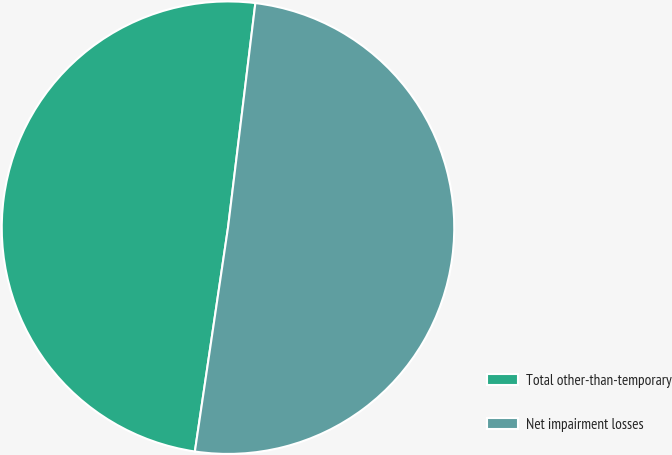<chart> <loc_0><loc_0><loc_500><loc_500><pie_chart><fcel>Total other-than-temporary<fcel>Net impairment losses<nl><fcel>49.59%<fcel>50.41%<nl></chart> 